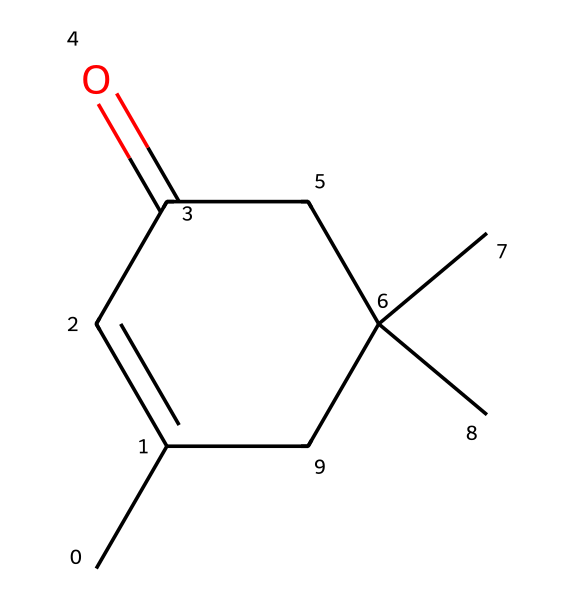What is the molecular formula of isophorone? The SMILES representation can be translated into a chemical structure, which consists of carbon (C) and hydrogen (H) atoms. By counting the atoms, we find the molecular formula is C10H16O.
Answer: C10H16O How many double bonds are present in isophorone? In the chemical structure derived from the SMILES, there is one carbon-oxygen double bond (the carbonyl group) and one double bond within the cyclohexene ring. This totals to two double bonds.
Answer: 2 What functional group is represented in isophorone? The carbonyl group (C=O) is present, which is characteristic of ketones. This can be observed as there is a carbon atom double-bonded to an oxygen in the molecule.
Answer: ketone How many chiral centers exist in isophorone? A chiral center is determined by the presence of a carbon atom bonded to four different substituents. In isophorone's structure, there are two such carbon atoms that fit this criterion.
Answer: 2 What is the significance of the isopropyl groups in isophorone? The two isopropyl groups increase the steric hindrance and influence the physical properties such as melting point and boiling point, which is important for its use in coatings.
Answer: steric hindrance What type of reaction can isophorone undergo in UV-curable coatings? Isophorone can undergo polymerization reactions when exposed to UV light, resulting in the cross-linking of molecules, which enhances the thermal and mechanical properties of coatings.
Answer: polymerization What is the boiling point trend for ketones like isophorone? Ketones typically have higher boiling points compared to similar hydrocarbons due to the polar carbonyl group, which contributes to intermolecular forces like dipole-dipole interactions and hydrogen bonding.
Answer: higher boiling points 